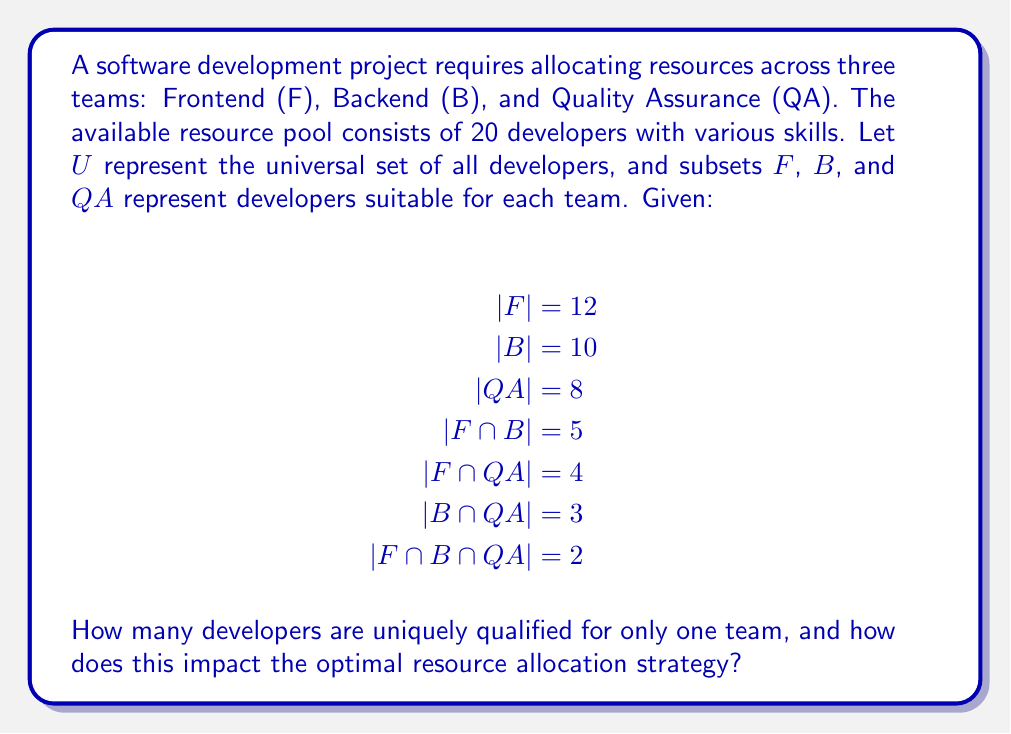Could you help me with this problem? To solve this problem, we'll use set theory principles and the inclusion-exclusion principle. Let's break it down step-by-step:

1. First, let's calculate the total number of developers qualified for at least one team:
   $$|F \cup B \cup QA| = |F| + |B| + |QA| - |F \cap B| - |F \cap QA| - |B \cap QA| + |F \cap B \cap QA|$$
   $$= 12 + 10 + 8 - 5 - 4 - 3 + 2 = 20$$

2. Now, let's calculate the number of developers qualified for exactly one team:
   - Only Frontend: $|F| - |F \cap B| - |F \cap QA| + |F \cap B \cap QA|$
   - Only Backend: $|B| - |F \cap B| - |B \cap QA| + |F \cap B \cap QA|$
   - Only QA: $|QA| - |F \cap QA| - |B \cap QA| + |F \cap B \cap QA|$

3. Calculate each:
   - Only Frontend: $12 - 5 - 4 + 2 = 5$
   - Only Backend: $10 - 5 - 3 + 2 = 4$
   - Only QA: $8 - 4 - 3 + 2 = 3$

4. Sum the results:
   Total uniquely qualified developers = $5 + 4 + 3 = 12$

Impact on optimal resource allocation strategy:
1. 12 out of 20 developers (60%) are uniquely qualified for one team, limiting flexibility in resource allocation.
2. Only 8 developers have multi-team skills, which can be leveraged for cross-team collaboration or to fill gaps.
3. The Frontend team has the most uniquely qualified developers (5), suggesting a potential need for specialized Frontend skills.
4. The QA team has the fewest uniquely qualified developers (3), indicating a possible shortage of dedicated QA specialists.
5. To optimize resource allocation:
   a. Prioritize assigning uniquely qualified developers to their respective teams.
   b. Utilize multi-skilled developers strategically to balance workloads and fill skill gaps.
   c. Consider cross-training opportunities, especially for QA, to increase flexibility.
   d. Monitor the Frontend team's workload, as they have the most specialized resources.
Answer: 12 developers are uniquely qualified for only one team. This impacts the optimal resource allocation strategy by limiting flexibility, necessitating strategic use of multi-skilled developers, and highlighting potential areas for cross-training and workload management. 